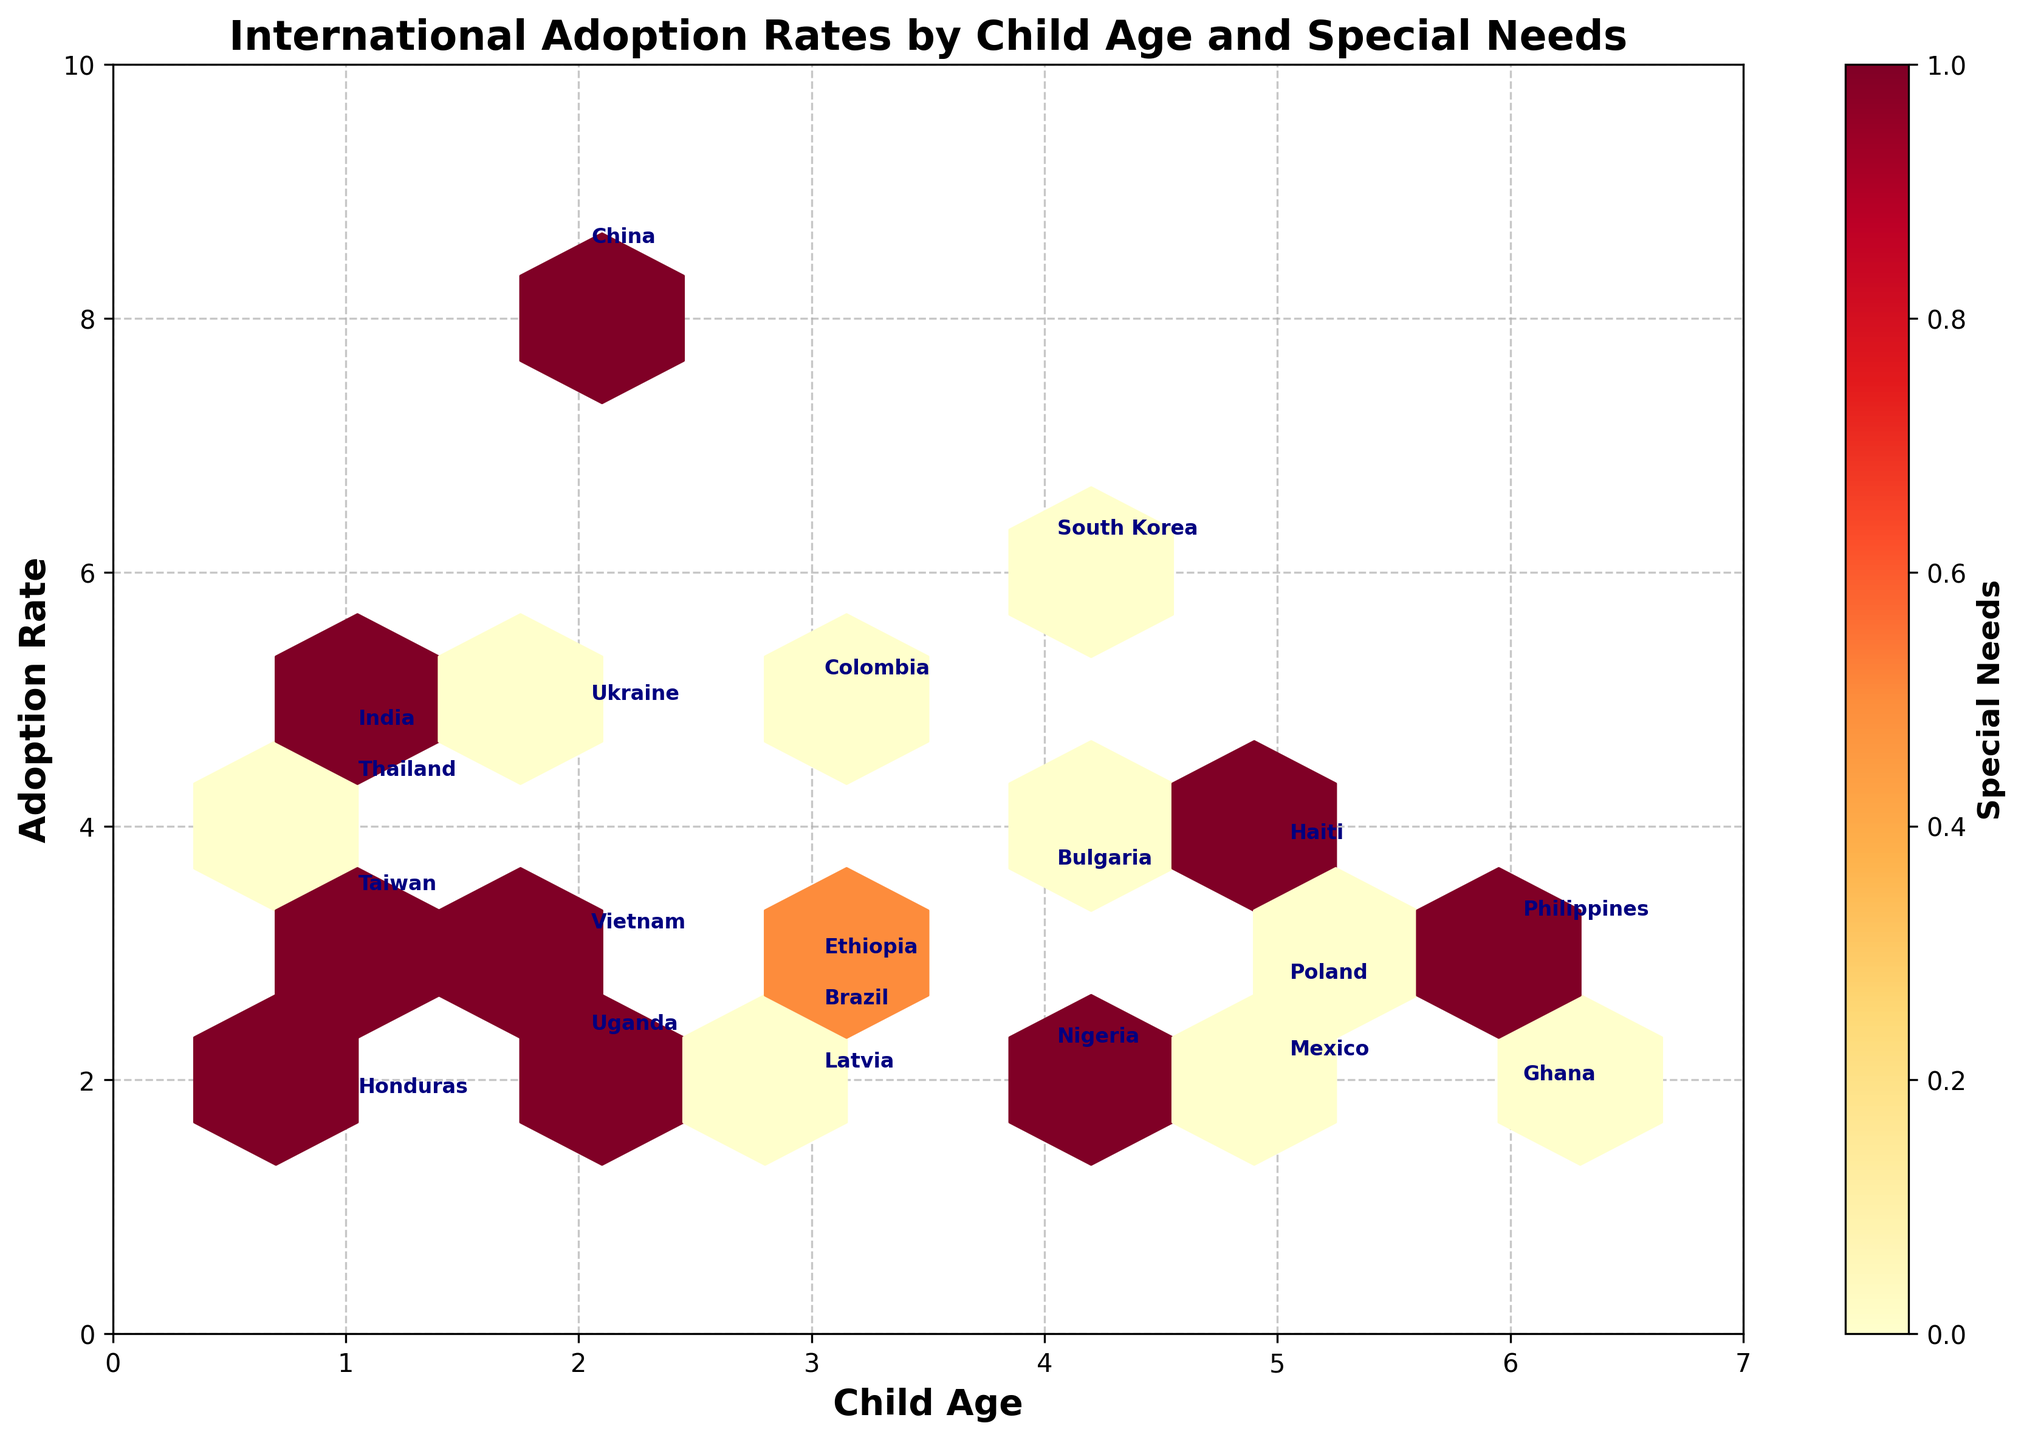What's the title of the figure? The title of the figure is prominently displayed at the top in bold font.
Answer: "International Adoption Rates by Child Age and Special Needs" What are the labels for the x and y axes? The labels for the axes are given by the text next to each respective axis. The x-axis is labeled "Child Age" and the y-axis is labeled "Adoption Rate".
Answer: "Child Age" and "Adoption Rate" How does the color intensity in the hexagons relate to the data? The color intensity of the hexagons indicates the concentration of children with special needs. Darker colors represent higher concentrations as shown by the color bar on the right labeled "Special Needs".
Answer: Higher color intensity indicates more children with special needs Which country has the highest adoption rate for children with special needs? By looking at the annotated country names and their corresponding hexagons, the highest adoption rate for children with special needs can be found near the top of the plot.
Answer: China What is the adoption rate and age for children adopted from Haiti? The plot shows the data points for each country, including Haiti, annotated with the country name. Haiti's position indicates its child age and adoption rate.
Answer: 5 years old and 3.8 Is there a general trend between child age and adoption rate based on the figure? By looking at the pattern formed by the hexagons, we can see if there is any trend between the x and y values. There doesn't appear to be a strong linear trend in either direction.
Answer: No clear trend Which country has the lowest adoption rate for non-special needs children? The figure highlights each country, and by examining the adoption rates for children without special needs (lighter colors), we can find the lowest rate.
Answer: Ghana Compare the adoption rate between children with and without special needs in China. By locating the hexagon representing China and its color intensity, as well as any annotated text, we can compare the adoption rates for different groups. China has a high adoption rate in a darker hexagon, indicating special needs.
Answer: Higher for special needs children (8.5 vs. 4.3) What is the average adoption rate for children aged 3 years across all countries? Find the adoption rate for all countries with 3 years of age, then calculate their average. The countries are Colombia, Brazil, Ethiopia, and Latvia with rates 5.1, 2.5, 2.9, and 2.0.
Answer: 3.13 Among the countries displayed, how many have an adoption rate of 4.0 or higher for children with special needs? Check the annotated countries and their corresponding hexagons for child age and adoption rate, then count the ones above 4.0 with special needs (based on color bar).
Answer: Three: China, South Korea, India 